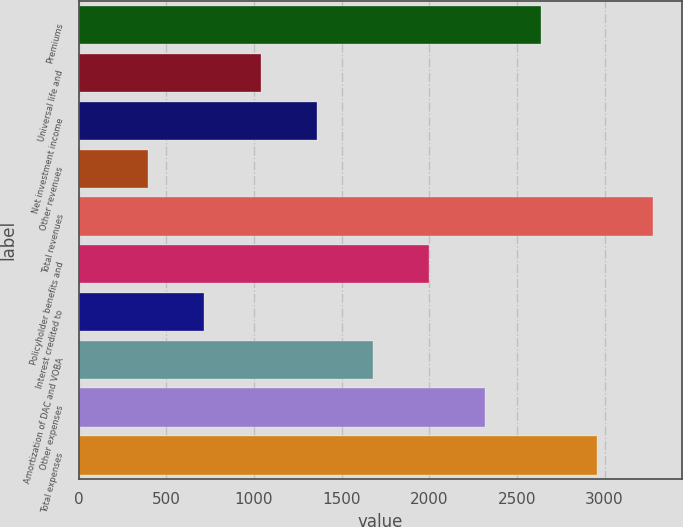Convert chart to OTSL. <chart><loc_0><loc_0><loc_500><loc_500><bar_chart><fcel>Premiums<fcel>Universal life and<fcel>Net investment income<fcel>Other revenues<fcel>Total revenues<fcel>Policyholder benefits and<fcel>Interest credited to<fcel>Amortization of DAC and VOBA<fcel>Other expenses<fcel>Total expenses<nl><fcel>2638<fcel>1038<fcel>1358<fcel>398<fcel>3278<fcel>1998<fcel>718<fcel>1678<fcel>2318<fcel>2958<nl></chart> 